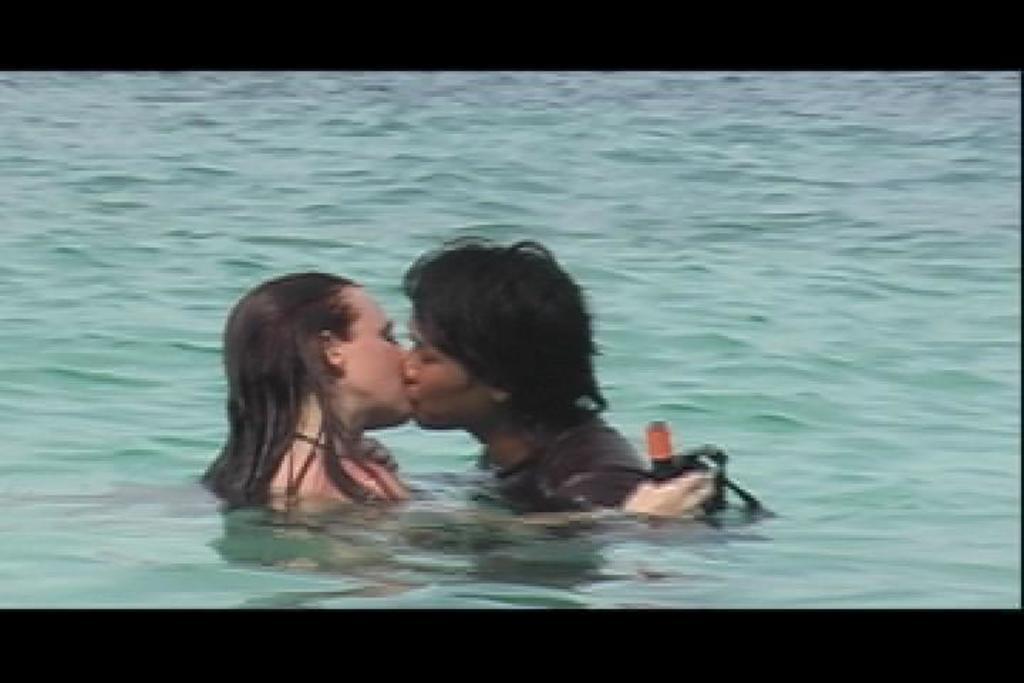How would you summarize this image in a sentence or two? In this image I can see the water. In the water there is a man and a woman are kissing. The woman is holding a black color object in the hand. 